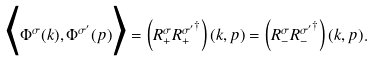<formula> <loc_0><loc_0><loc_500><loc_500>\Big < \Phi ^ { \sigma } ( k ) , \Phi ^ { \sigma ^ { \prime } } ( p ) \Big > = \left ( { R } ^ { \sigma } _ { + } { { R } ^ { \sigma ^ { \prime } } _ { + } } ^ { \dag } \right ) ( k , p ) = \left ( { R } ^ { \sigma } _ { - } { { R } ^ { \sigma ^ { \prime } } _ { - } } ^ { \dag } \right ) ( k , p ) .</formula> 